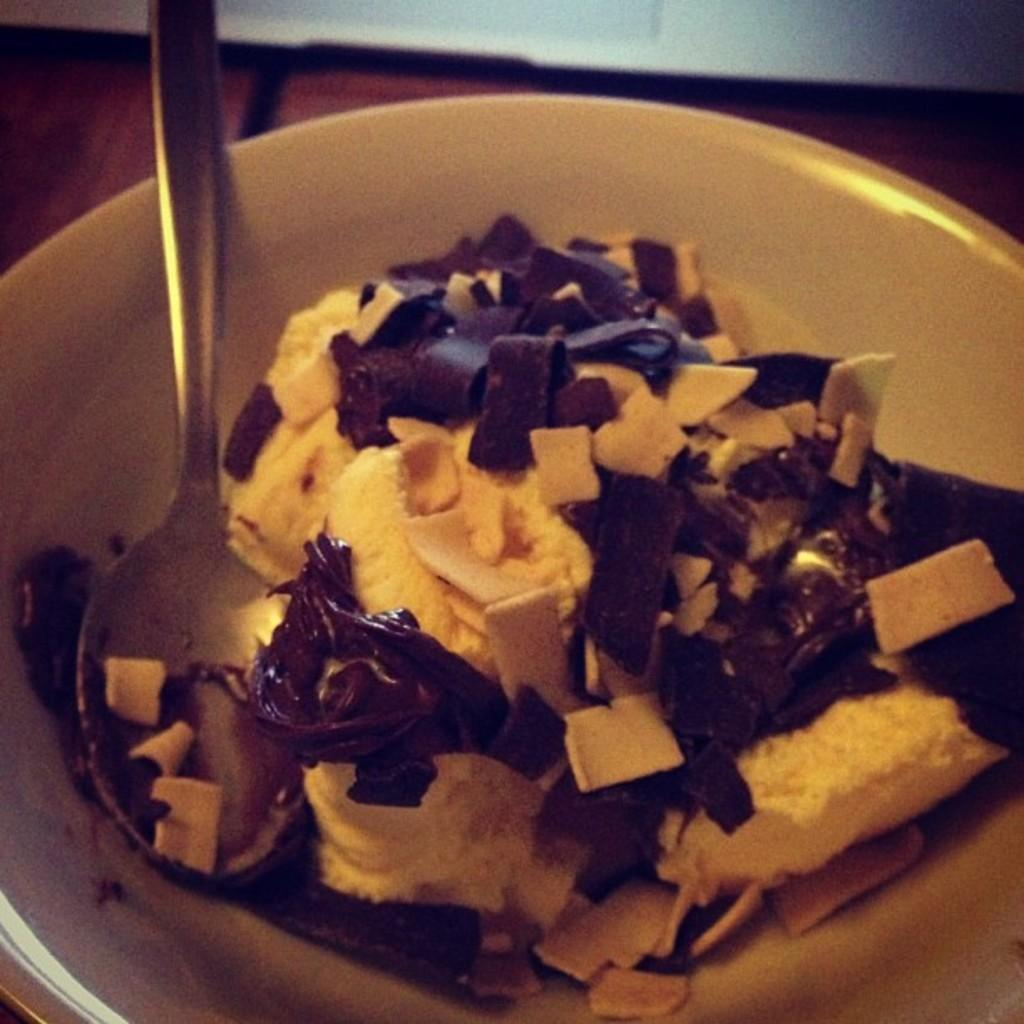What piece of furniture is present in the image? There is a table in the image. What is placed on the table? There is a bowl on the table. What is inside the bowl? There is a dish in the bowl. What utensil is present in the bowl? There is a spoon in the bowl. How would you describe the lighting in the image? The image is slightly dark. Is there a club, tent, or island visible in the image? No, there is no club, tent, or island present in the image. 